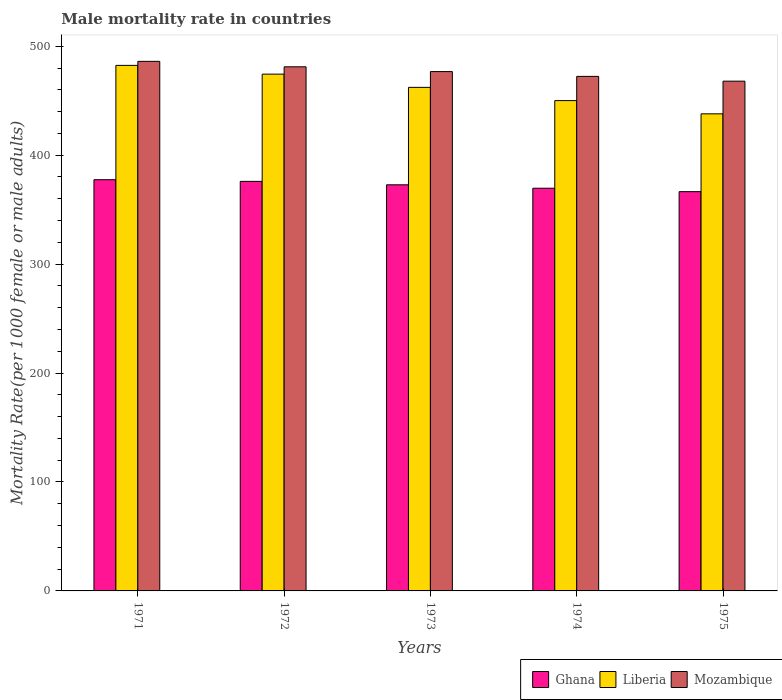How many different coloured bars are there?
Offer a very short reply. 3. How many bars are there on the 2nd tick from the left?
Provide a short and direct response. 3. How many bars are there on the 3rd tick from the right?
Provide a short and direct response. 3. What is the label of the 5th group of bars from the left?
Make the answer very short. 1975. What is the male mortality rate in Mozambique in 1974?
Make the answer very short. 472.36. Across all years, what is the maximum male mortality rate in Liberia?
Your response must be concise. 482.45. Across all years, what is the minimum male mortality rate in Ghana?
Your answer should be compact. 366.53. In which year was the male mortality rate in Ghana maximum?
Give a very brief answer. 1971. In which year was the male mortality rate in Mozambique minimum?
Provide a short and direct response. 1975. What is the total male mortality rate in Liberia in the graph?
Provide a short and direct response. 2307.21. What is the difference between the male mortality rate in Mozambique in 1971 and that in 1973?
Your answer should be very brief. 9.4. What is the difference between the male mortality rate in Liberia in 1975 and the male mortality rate in Mozambique in 1972?
Your answer should be very brief. -43.18. What is the average male mortality rate in Liberia per year?
Provide a short and direct response. 461.44. In the year 1971, what is the difference between the male mortality rate in Mozambique and male mortality rate in Ghana?
Your answer should be compact. 108.64. What is the ratio of the male mortality rate in Ghana in 1972 to that in 1973?
Your answer should be very brief. 1.01. Is the male mortality rate in Mozambique in 1971 less than that in 1973?
Your response must be concise. No. What is the difference between the highest and the second highest male mortality rate in Mozambique?
Offer a terse response. 5. What is the difference between the highest and the lowest male mortality rate in Mozambique?
Provide a short and direct response. 18.18. In how many years, is the male mortality rate in Mozambique greater than the average male mortality rate in Mozambique taken over all years?
Your answer should be very brief. 2. Is the sum of the male mortality rate in Mozambique in 1971 and 1974 greater than the maximum male mortality rate in Ghana across all years?
Your answer should be very brief. Yes. What does the 3rd bar from the left in 1971 represents?
Make the answer very short. Mozambique. What does the 3rd bar from the right in 1972 represents?
Ensure brevity in your answer.  Ghana. Is it the case that in every year, the sum of the male mortality rate in Ghana and male mortality rate in Liberia is greater than the male mortality rate in Mozambique?
Provide a short and direct response. Yes. How many years are there in the graph?
Ensure brevity in your answer.  5. What is the difference between two consecutive major ticks on the Y-axis?
Offer a very short reply. 100. Are the values on the major ticks of Y-axis written in scientific E-notation?
Your answer should be very brief. No. Does the graph contain any zero values?
Give a very brief answer. No. Where does the legend appear in the graph?
Make the answer very short. Bottom right. How many legend labels are there?
Your answer should be compact. 3. What is the title of the graph?
Make the answer very short. Male mortality rate in countries. What is the label or title of the X-axis?
Your answer should be compact. Years. What is the label or title of the Y-axis?
Ensure brevity in your answer.  Mortality Rate(per 1000 female or male adults). What is the Mortality Rate(per 1000 female or male adults) of Ghana in 1971?
Ensure brevity in your answer.  377.5. What is the Mortality Rate(per 1000 female or male adults) of Liberia in 1971?
Your answer should be compact. 482.45. What is the Mortality Rate(per 1000 female or male adults) of Mozambique in 1971?
Make the answer very short. 486.15. What is the Mortality Rate(per 1000 female or male adults) of Ghana in 1972?
Keep it short and to the point. 375.97. What is the Mortality Rate(per 1000 female or male adults) in Liberia in 1972?
Keep it short and to the point. 474.41. What is the Mortality Rate(per 1000 female or male adults) of Mozambique in 1972?
Give a very brief answer. 481.14. What is the Mortality Rate(per 1000 female or male adults) of Ghana in 1973?
Provide a succinct answer. 372.82. What is the Mortality Rate(per 1000 female or male adults) in Liberia in 1973?
Ensure brevity in your answer.  462.26. What is the Mortality Rate(per 1000 female or male adults) of Mozambique in 1973?
Offer a terse response. 476.75. What is the Mortality Rate(per 1000 female or male adults) of Ghana in 1974?
Offer a very short reply. 369.68. What is the Mortality Rate(per 1000 female or male adults) of Liberia in 1974?
Offer a very short reply. 450.12. What is the Mortality Rate(per 1000 female or male adults) of Mozambique in 1974?
Provide a short and direct response. 472.36. What is the Mortality Rate(per 1000 female or male adults) in Ghana in 1975?
Keep it short and to the point. 366.53. What is the Mortality Rate(per 1000 female or male adults) of Liberia in 1975?
Keep it short and to the point. 437.96. What is the Mortality Rate(per 1000 female or male adults) in Mozambique in 1975?
Give a very brief answer. 467.96. Across all years, what is the maximum Mortality Rate(per 1000 female or male adults) in Ghana?
Your answer should be compact. 377.5. Across all years, what is the maximum Mortality Rate(per 1000 female or male adults) in Liberia?
Offer a terse response. 482.45. Across all years, what is the maximum Mortality Rate(per 1000 female or male adults) of Mozambique?
Give a very brief answer. 486.15. Across all years, what is the minimum Mortality Rate(per 1000 female or male adults) in Ghana?
Offer a very short reply. 366.53. Across all years, what is the minimum Mortality Rate(per 1000 female or male adults) of Liberia?
Provide a short and direct response. 437.96. Across all years, what is the minimum Mortality Rate(per 1000 female or male adults) of Mozambique?
Give a very brief answer. 467.96. What is the total Mortality Rate(per 1000 female or male adults) in Ghana in the graph?
Offer a terse response. 1862.5. What is the total Mortality Rate(per 1000 female or male adults) of Liberia in the graph?
Offer a very short reply. 2307.21. What is the total Mortality Rate(per 1000 female or male adults) in Mozambique in the graph?
Give a very brief answer. 2384.36. What is the difference between the Mortality Rate(per 1000 female or male adults) of Ghana in 1971 and that in 1972?
Make the answer very short. 1.54. What is the difference between the Mortality Rate(per 1000 female or male adults) in Liberia in 1971 and that in 1972?
Offer a very short reply. 8.03. What is the difference between the Mortality Rate(per 1000 female or male adults) of Mozambique in 1971 and that in 1972?
Your response must be concise. 5. What is the difference between the Mortality Rate(per 1000 female or male adults) of Ghana in 1971 and that in 1973?
Your answer should be compact. 4.68. What is the difference between the Mortality Rate(per 1000 female or male adults) of Liberia in 1971 and that in 1973?
Your answer should be very brief. 20.18. What is the difference between the Mortality Rate(per 1000 female or male adults) of Mozambique in 1971 and that in 1973?
Offer a terse response. 9.4. What is the difference between the Mortality Rate(per 1000 female or male adults) of Ghana in 1971 and that in 1974?
Your answer should be very brief. 7.83. What is the difference between the Mortality Rate(per 1000 female or male adults) in Liberia in 1971 and that in 1974?
Ensure brevity in your answer.  32.33. What is the difference between the Mortality Rate(per 1000 female or male adults) in Mozambique in 1971 and that in 1974?
Offer a very short reply. 13.79. What is the difference between the Mortality Rate(per 1000 female or male adults) in Ghana in 1971 and that in 1975?
Provide a short and direct response. 10.98. What is the difference between the Mortality Rate(per 1000 female or male adults) in Liberia in 1971 and that in 1975?
Ensure brevity in your answer.  44.48. What is the difference between the Mortality Rate(per 1000 female or male adults) in Mozambique in 1971 and that in 1975?
Keep it short and to the point. 18.18. What is the difference between the Mortality Rate(per 1000 female or male adults) of Ghana in 1972 and that in 1973?
Make the answer very short. 3.15. What is the difference between the Mortality Rate(per 1000 female or male adults) in Liberia in 1972 and that in 1973?
Your answer should be very brief. 12.15. What is the difference between the Mortality Rate(per 1000 female or male adults) of Mozambique in 1972 and that in 1973?
Offer a terse response. 4.39. What is the difference between the Mortality Rate(per 1000 female or male adults) of Ghana in 1972 and that in 1974?
Ensure brevity in your answer.  6.29. What is the difference between the Mortality Rate(per 1000 female or male adults) of Liberia in 1972 and that in 1974?
Give a very brief answer. 24.3. What is the difference between the Mortality Rate(per 1000 female or male adults) in Mozambique in 1972 and that in 1974?
Offer a very short reply. 8.79. What is the difference between the Mortality Rate(per 1000 female or male adults) in Ghana in 1972 and that in 1975?
Keep it short and to the point. 9.44. What is the difference between the Mortality Rate(per 1000 female or male adults) in Liberia in 1972 and that in 1975?
Keep it short and to the point. 36.45. What is the difference between the Mortality Rate(per 1000 female or male adults) of Mozambique in 1972 and that in 1975?
Offer a terse response. 13.18. What is the difference between the Mortality Rate(per 1000 female or male adults) of Ghana in 1973 and that in 1974?
Give a very brief answer. 3.15. What is the difference between the Mortality Rate(per 1000 female or male adults) of Liberia in 1973 and that in 1974?
Provide a succinct answer. 12.15. What is the difference between the Mortality Rate(per 1000 female or male adults) of Mozambique in 1973 and that in 1974?
Provide a succinct answer. 4.39. What is the difference between the Mortality Rate(per 1000 female or male adults) in Ghana in 1973 and that in 1975?
Provide a succinct answer. 6.29. What is the difference between the Mortality Rate(per 1000 female or male adults) in Liberia in 1973 and that in 1975?
Provide a short and direct response. 24.3. What is the difference between the Mortality Rate(per 1000 female or male adults) of Mozambique in 1973 and that in 1975?
Your answer should be very brief. 8.79. What is the difference between the Mortality Rate(per 1000 female or male adults) of Ghana in 1974 and that in 1975?
Make the answer very short. 3.15. What is the difference between the Mortality Rate(per 1000 female or male adults) of Liberia in 1974 and that in 1975?
Your answer should be compact. 12.15. What is the difference between the Mortality Rate(per 1000 female or male adults) of Mozambique in 1974 and that in 1975?
Give a very brief answer. 4.39. What is the difference between the Mortality Rate(per 1000 female or male adults) of Ghana in 1971 and the Mortality Rate(per 1000 female or male adults) of Liberia in 1972?
Your answer should be very brief. -96.91. What is the difference between the Mortality Rate(per 1000 female or male adults) in Ghana in 1971 and the Mortality Rate(per 1000 female or male adults) in Mozambique in 1972?
Keep it short and to the point. -103.64. What is the difference between the Mortality Rate(per 1000 female or male adults) in Liberia in 1971 and the Mortality Rate(per 1000 female or male adults) in Mozambique in 1972?
Ensure brevity in your answer.  1.31. What is the difference between the Mortality Rate(per 1000 female or male adults) in Ghana in 1971 and the Mortality Rate(per 1000 female or male adults) in Liberia in 1973?
Provide a succinct answer. -84.76. What is the difference between the Mortality Rate(per 1000 female or male adults) in Ghana in 1971 and the Mortality Rate(per 1000 female or male adults) in Mozambique in 1973?
Your response must be concise. -99.25. What is the difference between the Mortality Rate(per 1000 female or male adults) in Liberia in 1971 and the Mortality Rate(per 1000 female or male adults) in Mozambique in 1973?
Ensure brevity in your answer.  5.7. What is the difference between the Mortality Rate(per 1000 female or male adults) in Ghana in 1971 and the Mortality Rate(per 1000 female or male adults) in Liberia in 1974?
Ensure brevity in your answer.  -72.61. What is the difference between the Mortality Rate(per 1000 female or male adults) of Ghana in 1971 and the Mortality Rate(per 1000 female or male adults) of Mozambique in 1974?
Ensure brevity in your answer.  -94.85. What is the difference between the Mortality Rate(per 1000 female or male adults) in Liberia in 1971 and the Mortality Rate(per 1000 female or male adults) in Mozambique in 1974?
Keep it short and to the point. 10.09. What is the difference between the Mortality Rate(per 1000 female or male adults) of Ghana in 1971 and the Mortality Rate(per 1000 female or male adults) of Liberia in 1975?
Provide a short and direct response. -60.46. What is the difference between the Mortality Rate(per 1000 female or male adults) in Ghana in 1971 and the Mortality Rate(per 1000 female or male adults) in Mozambique in 1975?
Make the answer very short. -90.46. What is the difference between the Mortality Rate(per 1000 female or male adults) of Liberia in 1971 and the Mortality Rate(per 1000 female or male adults) of Mozambique in 1975?
Your answer should be compact. 14.48. What is the difference between the Mortality Rate(per 1000 female or male adults) of Ghana in 1972 and the Mortality Rate(per 1000 female or male adults) of Liberia in 1973?
Your response must be concise. -86.3. What is the difference between the Mortality Rate(per 1000 female or male adults) of Ghana in 1972 and the Mortality Rate(per 1000 female or male adults) of Mozambique in 1973?
Your response must be concise. -100.78. What is the difference between the Mortality Rate(per 1000 female or male adults) in Liberia in 1972 and the Mortality Rate(per 1000 female or male adults) in Mozambique in 1973?
Your response must be concise. -2.34. What is the difference between the Mortality Rate(per 1000 female or male adults) of Ghana in 1972 and the Mortality Rate(per 1000 female or male adults) of Liberia in 1974?
Your answer should be compact. -74.15. What is the difference between the Mortality Rate(per 1000 female or male adults) of Ghana in 1972 and the Mortality Rate(per 1000 female or male adults) of Mozambique in 1974?
Your answer should be very brief. -96.39. What is the difference between the Mortality Rate(per 1000 female or male adults) of Liberia in 1972 and the Mortality Rate(per 1000 female or male adults) of Mozambique in 1974?
Make the answer very short. 2.06. What is the difference between the Mortality Rate(per 1000 female or male adults) of Ghana in 1972 and the Mortality Rate(per 1000 female or male adults) of Liberia in 1975?
Your response must be concise. -62. What is the difference between the Mortality Rate(per 1000 female or male adults) of Ghana in 1972 and the Mortality Rate(per 1000 female or male adults) of Mozambique in 1975?
Keep it short and to the point. -92. What is the difference between the Mortality Rate(per 1000 female or male adults) in Liberia in 1972 and the Mortality Rate(per 1000 female or male adults) in Mozambique in 1975?
Make the answer very short. 6.45. What is the difference between the Mortality Rate(per 1000 female or male adults) in Ghana in 1973 and the Mortality Rate(per 1000 female or male adults) in Liberia in 1974?
Make the answer very short. -77.29. What is the difference between the Mortality Rate(per 1000 female or male adults) in Ghana in 1973 and the Mortality Rate(per 1000 female or male adults) in Mozambique in 1974?
Ensure brevity in your answer.  -99.53. What is the difference between the Mortality Rate(per 1000 female or male adults) of Liberia in 1973 and the Mortality Rate(per 1000 female or male adults) of Mozambique in 1974?
Your answer should be compact. -10.09. What is the difference between the Mortality Rate(per 1000 female or male adults) of Ghana in 1973 and the Mortality Rate(per 1000 female or male adults) of Liberia in 1975?
Your response must be concise. -65.14. What is the difference between the Mortality Rate(per 1000 female or male adults) in Ghana in 1973 and the Mortality Rate(per 1000 female or male adults) in Mozambique in 1975?
Ensure brevity in your answer.  -95.14. What is the difference between the Mortality Rate(per 1000 female or male adults) of Liberia in 1973 and the Mortality Rate(per 1000 female or male adults) of Mozambique in 1975?
Your response must be concise. -5.7. What is the difference between the Mortality Rate(per 1000 female or male adults) in Ghana in 1974 and the Mortality Rate(per 1000 female or male adults) in Liberia in 1975?
Ensure brevity in your answer.  -68.29. What is the difference between the Mortality Rate(per 1000 female or male adults) of Ghana in 1974 and the Mortality Rate(per 1000 female or male adults) of Mozambique in 1975?
Provide a short and direct response. -98.29. What is the difference between the Mortality Rate(per 1000 female or male adults) in Liberia in 1974 and the Mortality Rate(per 1000 female or male adults) in Mozambique in 1975?
Your answer should be very brief. -17.85. What is the average Mortality Rate(per 1000 female or male adults) in Ghana per year?
Your response must be concise. 372.5. What is the average Mortality Rate(per 1000 female or male adults) in Liberia per year?
Ensure brevity in your answer.  461.44. What is the average Mortality Rate(per 1000 female or male adults) in Mozambique per year?
Your answer should be compact. 476.87. In the year 1971, what is the difference between the Mortality Rate(per 1000 female or male adults) of Ghana and Mortality Rate(per 1000 female or male adults) of Liberia?
Ensure brevity in your answer.  -104.94. In the year 1971, what is the difference between the Mortality Rate(per 1000 female or male adults) in Ghana and Mortality Rate(per 1000 female or male adults) in Mozambique?
Give a very brief answer. -108.64. In the year 1971, what is the difference between the Mortality Rate(per 1000 female or male adults) of Liberia and Mortality Rate(per 1000 female or male adults) of Mozambique?
Keep it short and to the point. -3.7. In the year 1972, what is the difference between the Mortality Rate(per 1000 female or male adults) in Ghana and Mortality Rate(per 1000 female or male adults) in Liberia?
Keep it short and to the point. -98.44. In the year 1972, what is the difference between the Mortality Rate(per 1000 female or male adults) in Ghana and Mortality Rate(per 1000 female or male adults) in Mozambique?
Your response must be concise. -105.17. In the year 1972, what is the difference between the Mortality Rate(per 1000 female or male adults) of Liberia and Mortality Rate(per 1000 female or male adults) of Mozambique?
Offer a terse response. -6.73. In the year 1973, what is the difference between the Mortality Rate(per 1000 female or male adults) in Ghana and Mortality Rate(per 1000 female or male adults) in Liberia?
Your response must be concise. -89.44. In the year 1973, what is the difference between the Mortality Rate(per 1000 female or male adults) of Ghana and Mortality Rate(per 1000 female or male adults) of Mozambique?
Give a very brief answer. -103.93. In the year 1973, what is the difference between the Mortality Rate(per 1000 female or male adults) in Liberia and Mortality Rate(per 1000 female or male adults) in Mozambique?
Give a very brief answer. -14.49. In the year 1974, what is the difference between the Mortality Rate(per 1000 female or male adults) in Ghana and Mortality Rate(per 1000 female or male adults) in Liberia?
Provide a succinct answer. -80.44. In the year 1974, what is the difference between the Mortality Rate(per 1000 female or male adults) in Ghana and Mortality Rate(per 1000 female or male adults) in Mozambique?
Keep it short and to the point. -102.68. In the year 1974, what is the difference between the Mortality Rate(per 1000 female or male adults) in Liberia and Mortality Rate(per 1000 female or male adults) in Mozambique?
Offer a very short reply. -22.24. In the year 1975, what is the difference between the Mortality Rate(per 1000 female or male adults) of Ghana and Mortality Rate(per 1000 female or male adults) of Liberia?
Your response must be concise. -71.44. In the year 1975, what is the difference between the Mortality Rate(per 1000 female or male adults) of Ghana and Mortality Rate(per 1000 female or male adults) of Mozambique?
Your response must be concise. -101.44. In the year 1975, what is the difference between the Mortality Rate(per 1000 female or male adults) of Liberia and Mortality Rate(per 1000 female or male adults) of Mozambique?
Your answer should be very brief. -30. What is the ratio of the Mortality Rate(per 1000 female or male adults) in Liberia in 1971 to that in 1972?
Provide a short and direct response. 1.02. What is the ratio of the Mortality Rate(per 1000 female or male adults) of Mozambique in 1971 to that in 1972?
Make the answer very short. 1.01. What is the ratio of the Mortality Rate(per 1000 female or male adults) in Ghana in 1971 to that in 1973?
Ensure brevity in your answer.  1.01. What is the ratio of the Mortality Rate(per 1000 female or male adults) in Liberia in 1971 to that in 1973?
Provide a short and direct response. 1.04. What is the ratio of the Mortality Rate(per 1000 female or male adults) in Mozambique in 1971 to that in 1973?
Make the answer very short. 1.02. What is the ratio of the Mortality Rate(per 1000 female or male adults) of Ghana in 1971 to that in 1974?
Provide a short and direct response. 1.02. What is the ratio of the Mortality Rate(per 1000 female or male adults) in Liberia in 1971 to that in 1974?
Offer a terse response. 1.07. What is the ratio of the Mortality Rate(per 1000 female or male adults) in Mozambique in 1971 to that in 1974?
Provide a short and direct response. 1.03. What is the ratio of the Mortality Rate(per 1000 female or male adults) of Ghana in 1971 to that in 1975?
Offer a very short reply. 1.03. What is the ratio of the Mortality Rate(per 1000 female or male adults) of Liberia in 1971 to that in 1975?
Ensure brevity in your answer.  1.1. What is the ratio of the Mortality Rate(per 1000 female or male adults) of Mozambique in 1971 to that in 1975?
Make the answer very short. 1.04. What is the ratio of the Mortality Rate(per 1000 female or male adults) of Ghana in 1972 to that in 1973?
Provide a succinct answer. 1.01. What is the ratio of the Mortality Rate(per 1000 female or male adults) in Liberia in 1972 to that in 1973?
Offer a terse response. 1.03. What is the ratio of the Mortality Rate(per 1000 female or male adults) of Mozambique in 1972 to that in 1973?
Your answer should be very brief. 1.01. What is the ratio of the Mortality Rate(per 1000 female or male adults) in Liberia in 1972 to that in 1974?
Give a very brief answer. 1.05. What is the ratio of the Mortality Rate(per 1000 female or male adults) of Mozambique in 1972 to that in 1974?
Provide a short and direct response. 1.02. What is the ratio of the Mortality Rate(per 1000 female or male adults) in Ghana in 1972 to that in 1975?
Offer a very short reply. 1.03. What is the ratio of the Mortality Rate(per 1000 female or male adults) in Liberia in 1972 to that in 1975?
Offer a terse response. 1.08. What is the ratio of the Mortality Rate(per 1000 female or male adults) in Mozambique in 1972 to that in 1975?
Give a very brief answer. 1.03. What is the ratio of the Mortality Rate(per 1000 female or male adults) of Ghana in 1973 to that in 1974?
Offer a very short reply. 1.01. What is the ratio of the Mortality Rate(per 1000 female or male adults) in Mozambique in 1973 to that in 1974?
Your answer should be compact. 1.01. What is the ratio of the Mortality Rate(per 1000 female or male adults) of Ghana in 1973 to that in 1975?
Your response must be concise. 1.02. What is the ratio of the Mortality Rate(per 1000 female or male adults) in Liberia in 1973 to that in 1975?
Ensure brevity in your answer.  1.06. What is the ratio of the Mortality Rate(per 1000 female or male adults) of Mozambique in 1973 to that in 1975?
Offer a very short reply. 1.02. What is the ratio of the Mortality Rate(per 1000 female or male adults) in Ghana in 1974 to that in 1975?
Offer a terse response. 1.01. What is the ratio of the Mortality Rate(per 1000 female or male adults) of Liberia in 1974 to that in 1975?
Give a very brief answer. 1.03. What is the ratio of the Mortality Rate(per 1000 female or male adults) in Mozambique in 1974 to that in 1975?
Your answer should be very brief. 1.01. What is the difference between the highest and the second highest Mortality Rate(per 1000 female or male adults) in Ghana?
Provide a short and direct response. 1.54. What is the difference between the highest and the second highest Mortality Rate(per 1000 female or male adults) of Liberia?
Offer a terse response. 8.03. What is the difference between the highest and the second highest Mortality Rate(per 1000 female or male adults) of Mozambique?
Give a very brief answer. 5. What is the difference between the highest and the lowest Mortality Rate(per 1000 female or male adults) in Ghana?
Provide a short and direct response. 10.98. What is the difference between the highest and the lowest Mortality Rate(per 1000 female or male adults) in Liberia?
Give a very brief answer. 44.48. What is the difference between the highest and the lowest Mortality Rate(per 1000 female or male adults) in Mozambique?
Ensure brevity in your answer.  18.18. 